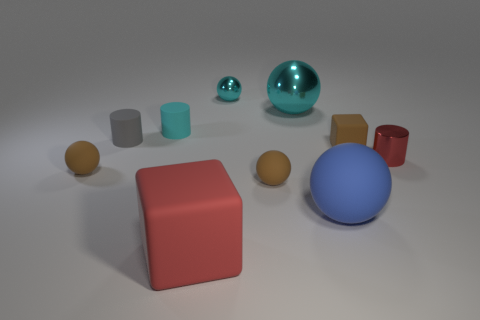How many objects in the scene are there, and can you categorize them by color? There are nine objects in the scene. Categorizing them by color: there are two blue objects (one large ball and one small ball), three brown objects (two small balls and a short cylinder), two red objects (a cube and a tall cylinder), and two grey objects (one cube and one cylinder). 